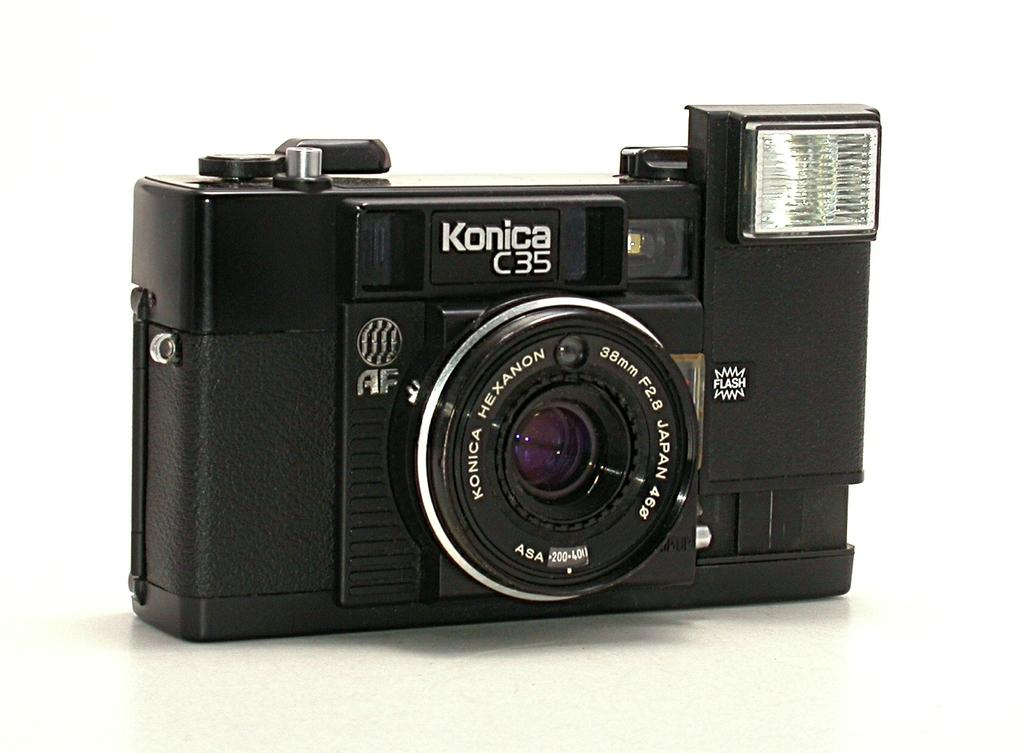What type of camera is visible in the image? There is a black color camera in the image. Can you describe any text or markings on the camera? Something is written on the camera. What color is the background of the image? The background of the image is white. What type of vest is being worn by the camera in the image? There is no vest present in the image, as the subject is a camera and not a person. 